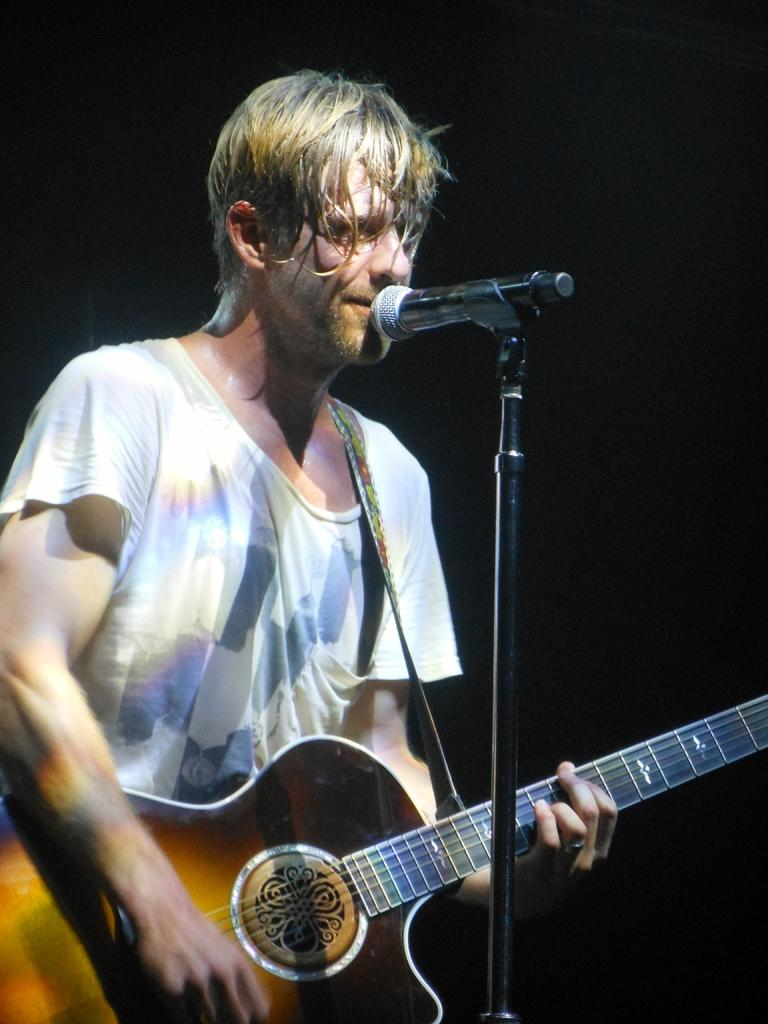What is the main subject of the image? The main subject of the image is a man. Can you describe the man's facial expression? The man has a smiling face. What is the man doing in the image? The man is playing a guitar. What type of doll can be seen playing the game with the man in the image? A: There is no doll or game present in the image; it features a man playing a guitar with a smiling face. 